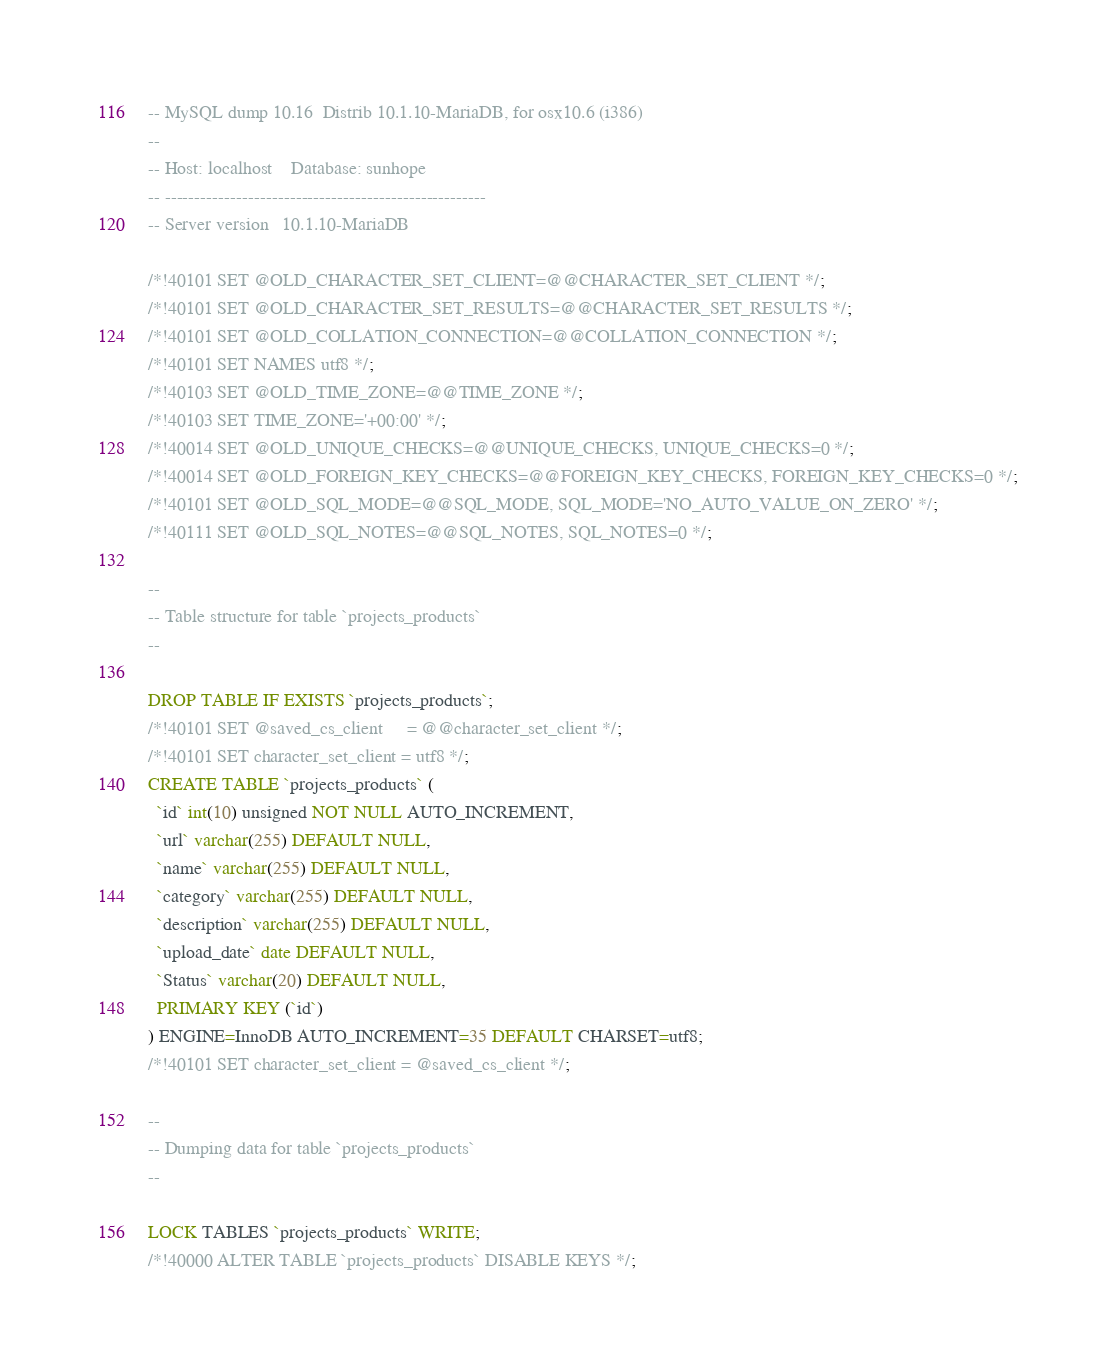<code> <loc_0><loc_0><loc_500><loc_500><_SQL_>-- MySQL dump 10.16  Distrib 10.1.10-MariaDB, for osx10.6 (i386)
--
-- Host: localhost    Database: sunhope
-- ------------------------------------------------------
-- Server version	10.1.10-MariaDB

/*!40101 SET @OLD_CHARACTER_SET_CLIENT=@@CHARACTER_SET_CLIENT */;
/*!40101 SET @OLD_CHARACTER_SET_RESULTS=@@CHARACTER_SET_RESULTS */;
/*!40101 SET @OLD_COLLATION_CONNECTION=@@COLLATION_CONNECTION */;
/*!40101 SET NAMES utf8 */;
/*!40103 SET @OLD_TIME_ZONE=@@TIME_ZONE */;
/*!40103 SET TIME_ZONE='+00:00' */;
/*!40014 SET @OLD_UNIQUE_CHECKS=@@UNIQUE_CHECKS, UNIQUE_CHECKS=0 */;
/*!40014 SET @OLD_FOREIGN_KEY_CHECKS=@@FOREIGN_KEY_CHECKS, FOREIGN_KEY_CHECKS=0 */;
/*!40101 SET @OLD_SQL_MODE=@@SQL_MODE, SQL_MODE='NO_AUTO_VALUE_ON_ZERO' */;
/*!40111 SET @OLD_SQL_NOTES=@@SQL_NOTES, SQL_NOTES=0 */;

--
-- Table structure for table `projects_products`
--

DROP TABLE IF EXISTS `projects_products`;
/*!40101 SET @saved_cs_client     = @@character_set_client */;
/*!40101 SET character_set_client = utf8 */;
CREATE TABLE `projects_products` (
  `id` int(10) unsigned NOT NULL AUTO_INCREMENT,
  `url` varchar(255) DEFAULT NULL,
  `name` varchar(255) DEFAULT NULL,
  `category` varchar(255) DEFAULT NULL,
  `description` varchar(255) DEFAULT NULL,
  `upload_date` date DEFAULT NULL,
  `Status` varchar(20) DEFAULT NULL,
  PRIMARY KEY (`id`)
) ENGINE=InnoDB AUTO_INCREMENT=35 DEFAULT CHARSET=utf8;
/*!40101 SET character_set_client = @saved_cs_client */;

--
-- Dumping data for table `projects_products`
--

LOCK TABLES `projects_products` WRITE;
/*!40000 ALTER TABLE `projects_products` DISABLE KEYS */;</code> 